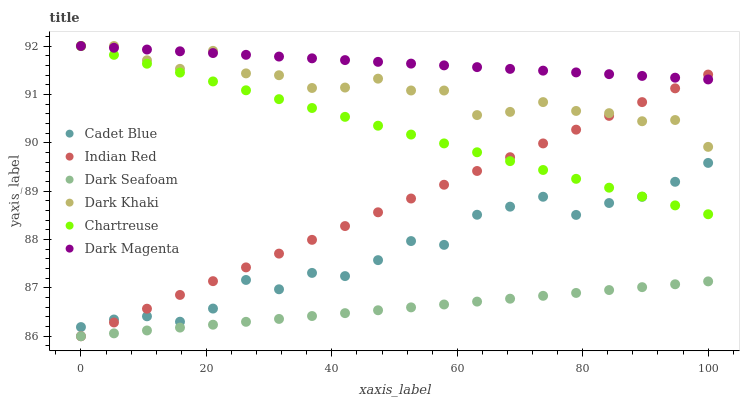Does Dark Seafoam have the minimum area under the curve?
Answer yes or no. Yes. Does Dark Magenta have the maximum area under the curve?
Answer yes or no. Yes. Does Chartreuse have the minimum area under the curve?
Answer yes or no. No. Does Chartreuse have the maximum area under the curve?
Answer yes or no. No. Is Dark Seafoam the smoothest?
Answer yes or no. Yes. Is Cadet Blue the roughest?
Answer yes or no. Yes. Is Dark Magenta the smoothest?
Answer yes or no. No. Is Dark Magenta the roughest?
Answer yes or no. No. Does Dark Seafoam have the lowest value?
Answer yes or no. Yes. Does Chartreuse have the lowest value?
Answer yes or no. No. Does Dark Khaki have the highest value?
Answer yes or no. Yes. Does Dark Seafoam have the highest value?
Answer yes or no. No. Is Dark Seafoam less than Dark Magenta?
Answer yes or no. Yes. Is Chartreuse greater than Dark Seafoam?
Answer yes or no. Yes. Does Chartreuse intersect Cadet Blue?
Answer yes or no. Yes. Is Chartreuse less than Cadet Blue?
Answer yes or no. No. Is Chartreuse greater than Cadet Blue?
Answer yes or no. No. Does Dark Seafoam intersect Dark Magenta?
Answer yes or no. No. 